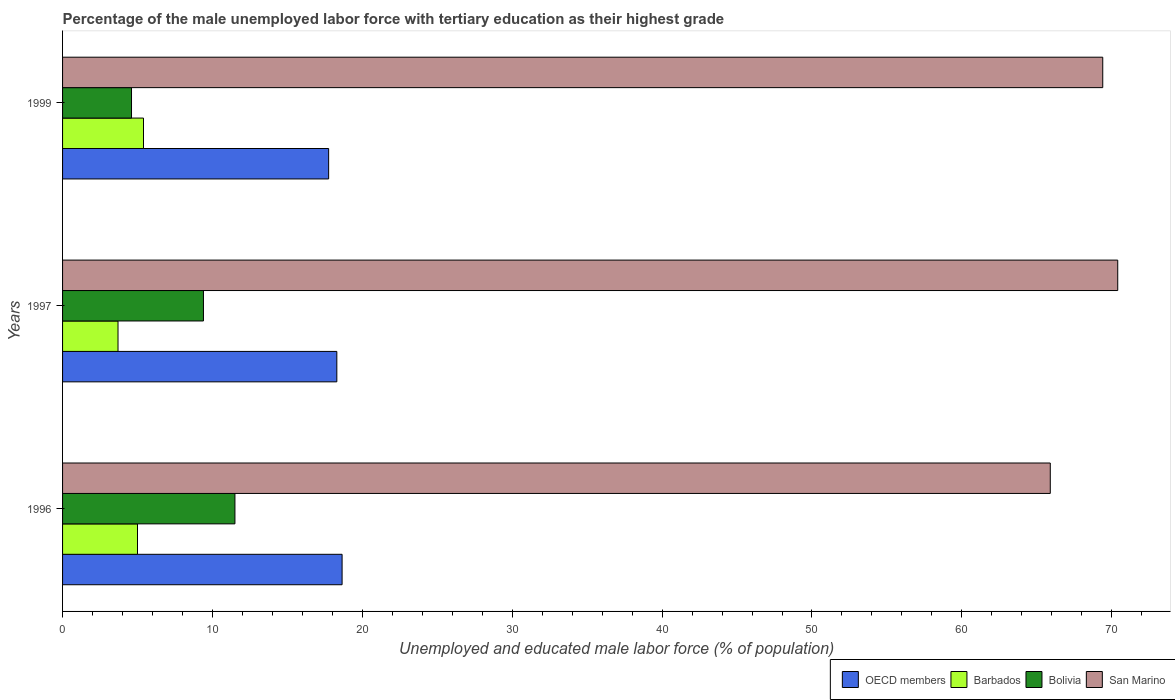How many groups of bars are there?
Provide a short and direct response. 3. Are the number of bars on each tick of the Y-axis equal?
Keep it short and to the point. Yes. How many bars are there on the 3rd tick from the top?
Keep it short and to the point. 4. What is the label of the 3rd group of bars from the top?
Your response must be concise. 1996. In how many cases, is the number of bars for a given year not equal to the number of legend labels?
Make the answer very short. 0. What is the percentage of the unemployed male labor force with tertiary education in Bolivia in 1999?
Your response must be concise. 4.6. Across all years, what is the maximum percentage of the unemployed male labor force with tertiary education in Bolivia?
Give a very brief answer. 11.5. Across all years, what is the minimum percentage of the unemployed male labor force with tertiary education in Barbados?
Ensure brevity in your answer.  3.7. In which year was the percentage of the unemployed male labor force with tertiary education in Barbados maximum?
Ensure brevity in your answer.  1999. In which year was the percentage of the unemployed male labor force with tertiary education in Barbados minimum?
Offer a terse response. 1997. What is the total percentage of the unemployed male labor force with tertiary education in Bolivia in the graph?
Provide a short and direct response. 25.5. What is the difference between the percentage of the unemployed male labor force with tertiary education in San Marino in 1997 and that in 1999?
Provide a succinct answer. 1. What is the difference between the percentage of the unemployed male labor force with tertiary education in Barbados in 1996 and the percentage of the unemployed male labor force with tertiary education in Bolivia in 1997?
Offer a terse response. -4.4. What is the average percentage of the unemployed male labor force with tertiary education in San Marino per year?
Provide a short and direct response. 68.57. What is the ratio of the percentage of the unemployed male labor force with tertiary education in Bolivia in 1997 to that in 1999?
Offer a terse response. 2.04. Is the difference between the percentage of the unemployed male labor force with tertiary education in Barbados in 1997 and 1999 greater than the difference between the percentage of the unemployed male labor force with tertiary education in Bolivia in 1997 and 1999?
Ensure brevity in your answer.  No. What is the difference between the highest and the second highest percentage of the unemployed male labor force with tertiary education in Barbados?
Give a very brief answer. 0.4. What is the difference between the highest and the lowest percentage of the unemployed male labor force with tertiary education in OECD members?
Provide a succinct answer. 0.9. Is it the case that in every year, the sum of the percentage of the unemployed male labor force with tertiary education in OECD members and percentage of the unemployed male labor force with tertiary education in Barbados is greater than the sum of percentage of the unemployed male labor force with tertiary education in San Marino and percentage of the unemployed male labor force with tertiary education in Bolivia?
Provide a succinct answer. Yes. What does the 1st bar from the top in 1996 represents?
Ensure brevity in your answer.  San Marino. What does the 1st bar from the bottom in 1996 represents?
Offer a very short reply. OECD members. Is it the case that in every year, the sum of the percentage of the unemployed male labor force with tertiary education in San Marino and percentage of the unemployed male labor force with tertiary education in Bolivia is greater than the percentage of the unemployed male labor force with tertiary education in Barbados?
Provide a succinct answer. Yes. How many bars are there?
Make the answer very short. 12. Are all the bars in the graph horizontal?
Your response must be concise. Yes. How many years are there in the graph?
Provide a succinct answer. 3. What is the difference between two consecutive major ticks on the X-axis?
Your answer should be compact. 10. Does the graph contain any zero values?
Offer a terse response. No. Where does the legend appear in the graph?
Keep it short and to the point. Bottom right. How are the legend labels stacked?
Ensure brevity in your answer.  Horizontal. What is the title of the graph?
Offer a terse response. Percentage of the male unemployed labor force with tertiary education as their highest grade. Does "Togo" appear as one of the legend labels in the graph?
Make the answer very short. No. What is the label or title of the X-axis?
Make the answer very short. Unemployed and educated male labor force (% of population). What is the Unemployed and educated male labor force (% of population) in OECD members in 1996?
Provide a short and direct response. 18.65. What is the Unemployed and educated male labor force (% of population) in Barbados in 1996?
Provide a succinct answer. 5. What is the Unemployed and educated male labor force (% of population) in Bolivia in 1996?
Your answer should be compact. 11.5. What is the Unemployed and educated male labor force (% of population) of San Marino in 1996?
Provide a short and direct response. 65.9. What is the Unemployed and educated male labor force (% of population) of OECD members in 1997?
Your answer should be very brief. 18.3. What is the Unemployed and educated male labor force (% of population) in Barbados in 1997?
Your response must be concise. 3.7. What is the Unemployed and educated male labor force (% of population) in Bolivia in 1997?
Your response must be concise. 9.4. What is the Unemployed and educated male labor force (% of population) of San Marino in 1997?
Give a very brief answer. 70.4. What is the Unemployed and educated male labor force (% of population) of OECD members in 1999?
Provide a short and direct response. 17.75. What is the Unemployed and educated male labor force (% of population) of Barbados in 1999?
Offer a very short reply. 5.4. What is the Unemployed and educated male labor force (% of population) in Bolivia in 1999?
Ensure brevity in your answer.  4.6. What is the Unemployed and educated male labor force (% of population) of San Marino in 1999?
Provide a succinct answer. 69.4. Across all years, what is the maximum Unemployed and educated male labor force (% of population) in OECD members?
Offer a very short reply. 18.65. Across all years, what is the maximum Unemployed and educated male labor force (% of population) of Barbados?
Ensure brevity in your answer.  5.4. Across all years, what is the maximum Unemployed and educated male labor force (% of population) of Bolivia?
Provide a short and direct response. 11.5. Across all years, what is the maximum Unemployed and educated male labor force (% of population) of San Marino?
Your response must be concise. 70.4. Across all years, what is the minimum Unemployed and educated male labor force (% of population) of OECD members?
Offer a very short reply. 17.75. Across all years, what is the minimum Unemployed and educated male labor force (% of population) of Barbados?
Offer a very short reply. 3.7. Across all years, what is the minimum Unemployed and educated male labor force (% of population) in Bolivia?
Provide a succinct answer. 4.6. Across all years, what is the minimum Unemployed and educated male labor force (% of population) of San Marino?
Keep it short and to the point. 65.9. What is the total Unemployed and educated male labor force (% of population) of OECD members in the graph?
Ensure brevity in your answer.  54.7. What is the total Unemployed and educated male labor force (% of population) of Barbados in the graph?
Keep it short and to the point. 14.1. What is the total Unemployed and educated male labor force (% of population) in Bolivia in the graph?
Offer a very short reply. 25.5. What is the total Unemployed and educated male labor force (% of population) of San Marino in the graph?
Your response must be concise. 205.7. What is the difference between the Unemployed and educated male labor force (% of population) of OECD members in 1996 and that in 1997?
Your response must be concise. 0.35. What is the difference between the Unemployed and educated male labor force (% of population) in Barbados in 1996 and that in 1997?
Keep it short and to the point. 1.3. What is the difference between the Unemployed and educated male labor force (% of population) in Bolivia in 1996 and that in 1997?
Keep it short and to the point. 2.1. What is the difference between the Unemployed and educated male labor force (% of population) of OECD members in 1996 and that in 1999?
Your response must be concise. 0.9. What is the difference between the Unemployed and educated male labor force (% of population) of Barbados in 1996 and that in 1999?
Your response must be concise. -0.4. What is the difference between the Unemployed and educated male labor force (% of population) of OECD members in 1997 and that in 1999?
Give a very brief answer. 0.55. What is the difference between the Unemployed and educated male labor force (% of population) of Barbados in 1997 and that in 1999?
Provide a succinct answer. -1.7. What is the difference between the Unemployed and educated male labor force (% of population) in Bolivia in 1997 and that in 1999?
Keep it short and to the point. 4.8. What is the difference between the Unemployed and educated male labor force (% of population) in San Marino in 1997 and that in 1999?
Offer a very short reply. 1. What is the difference between the Unemployed and educated male labor force (% of population) in OECD members in 1996 and the Unemployed and educated male labor force (% of population) in Barbados in 1997?
Keep it short and to the point. 14.95. What is the difference between the Unemployed and educated male labor force (% of population) of OECD members in 1996 and the Unemployed and educated male labor force (% of population) of Bolivia in 1997?
Provide a succinct answer. 9.25. What is the difference between the Unemployed and educated male labor force (% of population) in OECD members in 1996 and the Unemployed and educated male labor force (% of population) in San Marino in 1997?
Your answer should be compact. -51.75. What is the difference between the Unemployed and educated male labor force (% of population) of Barbados in 1996 and the Unemployed and educated male labor force (% of population) of Bolivia in 1997?
Keep it short and to the point. -4.4. What is the difference between the Unemployed and educated male labor force (% of population) in Barbados in 1996 and the Unemployed and educated male labor force (% of population) in San Marino in 1997?
Keep it short and to the point. -65.4. What is the difference between the Unemployed and educated male labor force (% of population) in Bolivia in 1996 and the Unemployed and educated male labor force (% of population) in San Marino in 1997?
Your answer should be compact. -58.9. What is the difference between the Unemployed and educated male labor force (% of population) in OECD members in 1996 and the Unemployed and educated male labor force (% of population) in Barbados in 1999?
Provide a short and direct response. 13.25. What is the difference between the Unemployed and educated male labor force (% of population) in OECD members in 1996 and the Unemployed and educated male labor force (% of population) in Bolivia in 1999?
Provide a short and direct response. 14.05. What is the difference between the Unemployed and educated male labor force (% of population) in OECD members in 1996 and the Unemployed and educated male labor force (% of population) in San Marino in 1999?
Give a very brief answer. -50.75. What is the difference between the Unemployed and educated male labor force (% of population) in Barbados in 1996 and the Unemployed and educated male labor force (% of population) in San Marino in 1999?
Make the answer very short. -64.4. What is the difference between the Unemployed and educated male labor force (% of population) in Bolivia in 1996 and the Unemployed and educated male labor force (% of population) in San Marino in 1999?
Your response must be concise. -57.9. What is the difference between the Unemployed and educated male labor force (% of population) of OECD members in 1997 and the Unemployed and educated male labor force (% of population) of Barbados in 1999?
Offer a terse response. 12.9. What is the difference between the Unemployed and educated male labor force (% of population) of OECD members in 1997 and the Unemployed and educated male labor force (% of population) of Bolivia in 1999?
Keep it short and to the point. 13.7. What is the difference between the Unemployed and educated male labor force (% of population) in OECD members in 1997 and the Unemployed and educated male labor force (% of population) in San Marino in 1999?
Offer a terse response. -51.1. What is the difference between the Unemployed and educated male labor force (% of population) in Barbados in 1997 and the Unemployed and educated male labor force (% of population) in San Marino in 1999?
Offer a very short reply. -65.7. What is the difference between the Unemployed and educated male labor force (% of population) of Bolivia in 1997 and the Unemployed and educated male labor force (% of population) of San Marino in 1999?
Offer a very short reply. -60. What is the average Unemployed and educated male labor force (% of population) in OECD members per year?
Keep it short and to the point. 18.23. What is the average Unemployed and educated male labor force (% of population) in San Marino per year?
Keep it short and to the point. 68.57. In the year 1996, what is the difference between the Unemployed and educated male labor force (% of population) in OECD members and Unemployed and educated male labor force (% of population) in Barbados?
Ensure brevity in your answer.  13.65. In the year 1996, what is the difference between the Unemployed and educated male labor force (% of population) in OECD members and Unemployed and educated male labor force (% of population) in Bolivia?
Ensure brevity in your answer.  7.15. In the year 1996, what is the difference between the Unemployed and educated male labor force (% of population) of OECD members and Unemployed and educated male labor force (% of population) of San Marino?
Your answer should be compact. -47.25. In the year 1996, what is the difference between the Unemployed and educated male labor force (% of population) in Barbados and Unemployed and educated male labor force (% of population) in Bolivia?
Provide a short and direct response. -6.5. In the year 1996, what is the difference between the Unemployed and educated male labor force (% of population) of Barbados and Unemployed and educated male labor force (% of population) of San Marino?
Ensure brevity in your answer.  -60.9. In the year 1996, what is the difference between the Unemployed and educated male labor force (% of population) of Bolivia and Unemployed and educated male labor force (% of population) of San Marino?
Give a very brief answer. -54.4. In the year 1997, what is the difference between the Unemployed and educated male labor force (% of population) of OECD members and Unemployed and educated male labor force (% of population) of Barbados?
Provide a short and direct response. 14.6. In the year 1997, what is the difference between the Unemployed and educated male labor force (% of population) of OECD members and Unemployed and educated male labor force (% of population) of Bolivia?
Your answer should be compact. 8.9. In the year 1997, what is the difference between the Unemployed and educated male labor force (% of population) of OECD members and Unemployed and educated male labor force (% of population) of San Marino?
Ensure brevity in your answer.  -52.1. In the year 1997, what is the difference between the Unemployed and educated male labor force (% of population) in Barbados and Unemployed and educated male labor force (% of population) in San Marino?
Offer a terse response. -66.7. In the year 1997, what is the difference between the Unemployed and educated male labor force (% of population) in Bolivia and Unemployed and educated male labor force (% of population) in San Marino?
Make the answer very short. -61. In the year 1999, what is the difference between the Unemployed and educated male labor force (% of population) in OECD members and Unemployed and educated male labor force (% of population) in Barbados?
Your answer should be very brief. 12.35. In the year 1999, what is the difference between the Unemployed and educated male labor force (% of population) in OECD members and Unemployed and educated male labor force (% of population) in Bolivia?
Your response must be concise. 13.15. In the year 1999, what is the difference between the Unemployed and educated male labor force (% of population) in OECD members and Unemployed and educated male labor force (% of population) in San Marino?
Your response must be concise. -51.65. In the year 1999, what is the difference between the Unemployed and educated male labor force (% of population) in Barbados and Unemployed and educated male labor force (% of population) in Bolivia?
Offer a terse response. 0.8. In the year 1999, what is the difference between the Unemployed and educated male labor force (% of population) of Barbados and Unemployed and educated male labor force (% of population) of San Marino?
Make the answer very short. -64. In the year 1999, what is the difference between the Unemployed and educated male labor force (% of population) in Bolivia and Unemployed and educated male labor force (% of population) in San Marino?
Offer a terse response. -64.8. What is the ratio of the Unemployed and educated male labor force (% of population) in OECD members in 1996 to that in 1997?
Your response must be concise. 1.02. What is the ratio of the Unemployed and educated male labor force (% of population) of Barbados in 1996 to that in 1997?
Your response must be concise. 1.35. What is the ratio of the Unemployed and educated male labor force (% of population) of Bolivia in 1996 to that in 1997?
Your response must be concise. 1.22. What is the ratio of the Unemployed and educated male labor force (% of population) in San Marino in 1996 to that in 1997?
Your response must be concise. 0.94. What is the ratio of the Unemployed and educated male labor force (% of population) of OECD members in 1996 to that in 1999?
Keep it short and to the point. 1.05. What is the ratio of the Unemployed and educated male labor force (% of population) of Barbados in 1996 to that in 1999?
Your answer should be very brief. 0.93. What is the ratio of the Unemployed and educated male labor force (% of population) of Bolivia in 1996 to that in 1999?
Provide a succinct answer. 2.5. What is the ratio of the Unemployed and educated male labor force (% of population) in San Marino in 1996 to that in 1999?
Offer a terse response. 0.95. What is the ratio of the Unemployed and educated male labor force (% of population) in OECD members in 1997 to that in 1999?
Provide a succinct answer. 1.03. What is the ratio of the Unemployed and educated male labor force (% of population) in Barbados in 1997 to that in 1999?
Ensure brevity in your answer.  0.69. What is the ratio of the Unemployed and educated male labor force (% of population) of Bolivia in 1997 to that in 1999?
Your response must be concise. 2.04. What is the ratio of the Unemployed and educated male labor force (% of population) of San Marino in 1997 to that in 1999?
Ensure brevity in your answer.  1.01. What is the difference between the highest and the second highest Unemployed and educated male labor force (% of population) of OECD members?
Provide a short and direct response. 0.35. What is the difference between the highest and the second highest Unemployed and educated male labor force (% of population) of Barbados?
Your response must be concise. 0.4. What is the difference between the highest and the second highest Unemployed and educated male labor force (% of population) in San Marino?
Give a very brief answer. 1. What is the difference between the highest and the lowest Unemployed and educated male labor force (% of population) of OECD members?
Provide a succinct answer. 0.9. What is the difference between the highest and the lowest Unemployed and educated male labor force (% of population) in Barbados?
Provide a short and direct response. 1.7. What is the difference between the highest and the lowest Unemployed and educated male labor force (% of population) of Bolivia?
Your answer should be very brief. 6.9. 